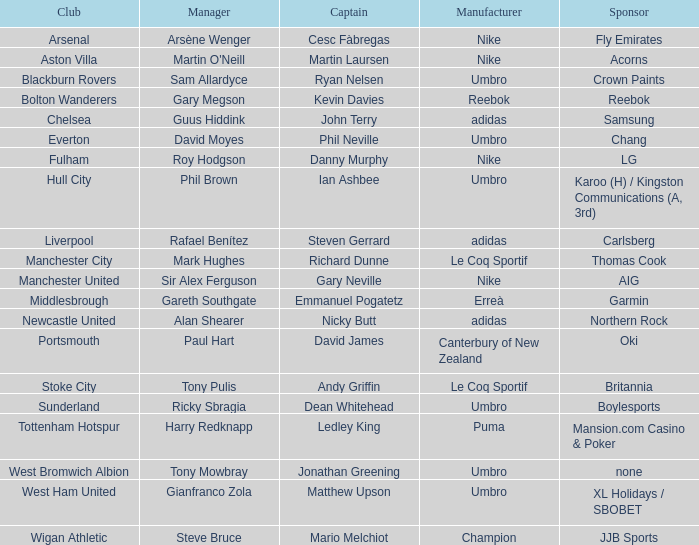In which club is Ledley King a captain? Tottenham Hotspur. 